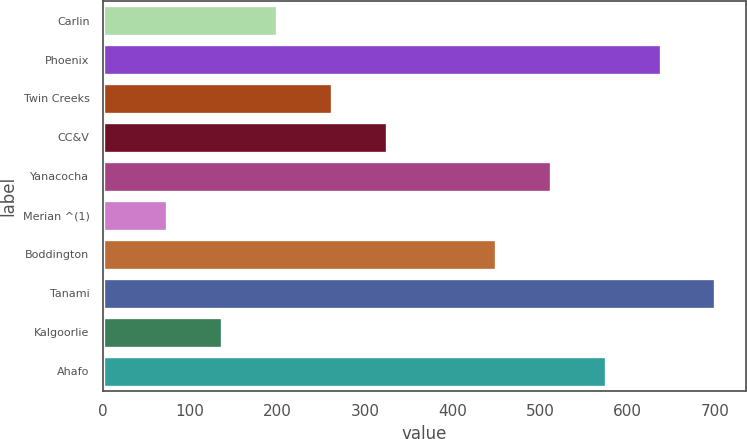Convert chart to OTSL. <chart><loc_0><loc_0><loc_500><loc_500><bar_chart><fcel>Carlin<fcel>Phoenix<fcel>Twin Creeks<fcel>CC&V<fcel>Yanacocha<fcel>Merian ^(1)<fcel>Boddington<fcel>Tanami<fcel>Kalgoorlie<fcel>Ahafo<nl><fcel>199.28<fcel>637.76<fcel>261.92<fcel>324.56<fcel>512.48<fcel>74<fcel>449.84<fcel>700.4<fcel>136.64<fcel>575.12<nl></chart> 